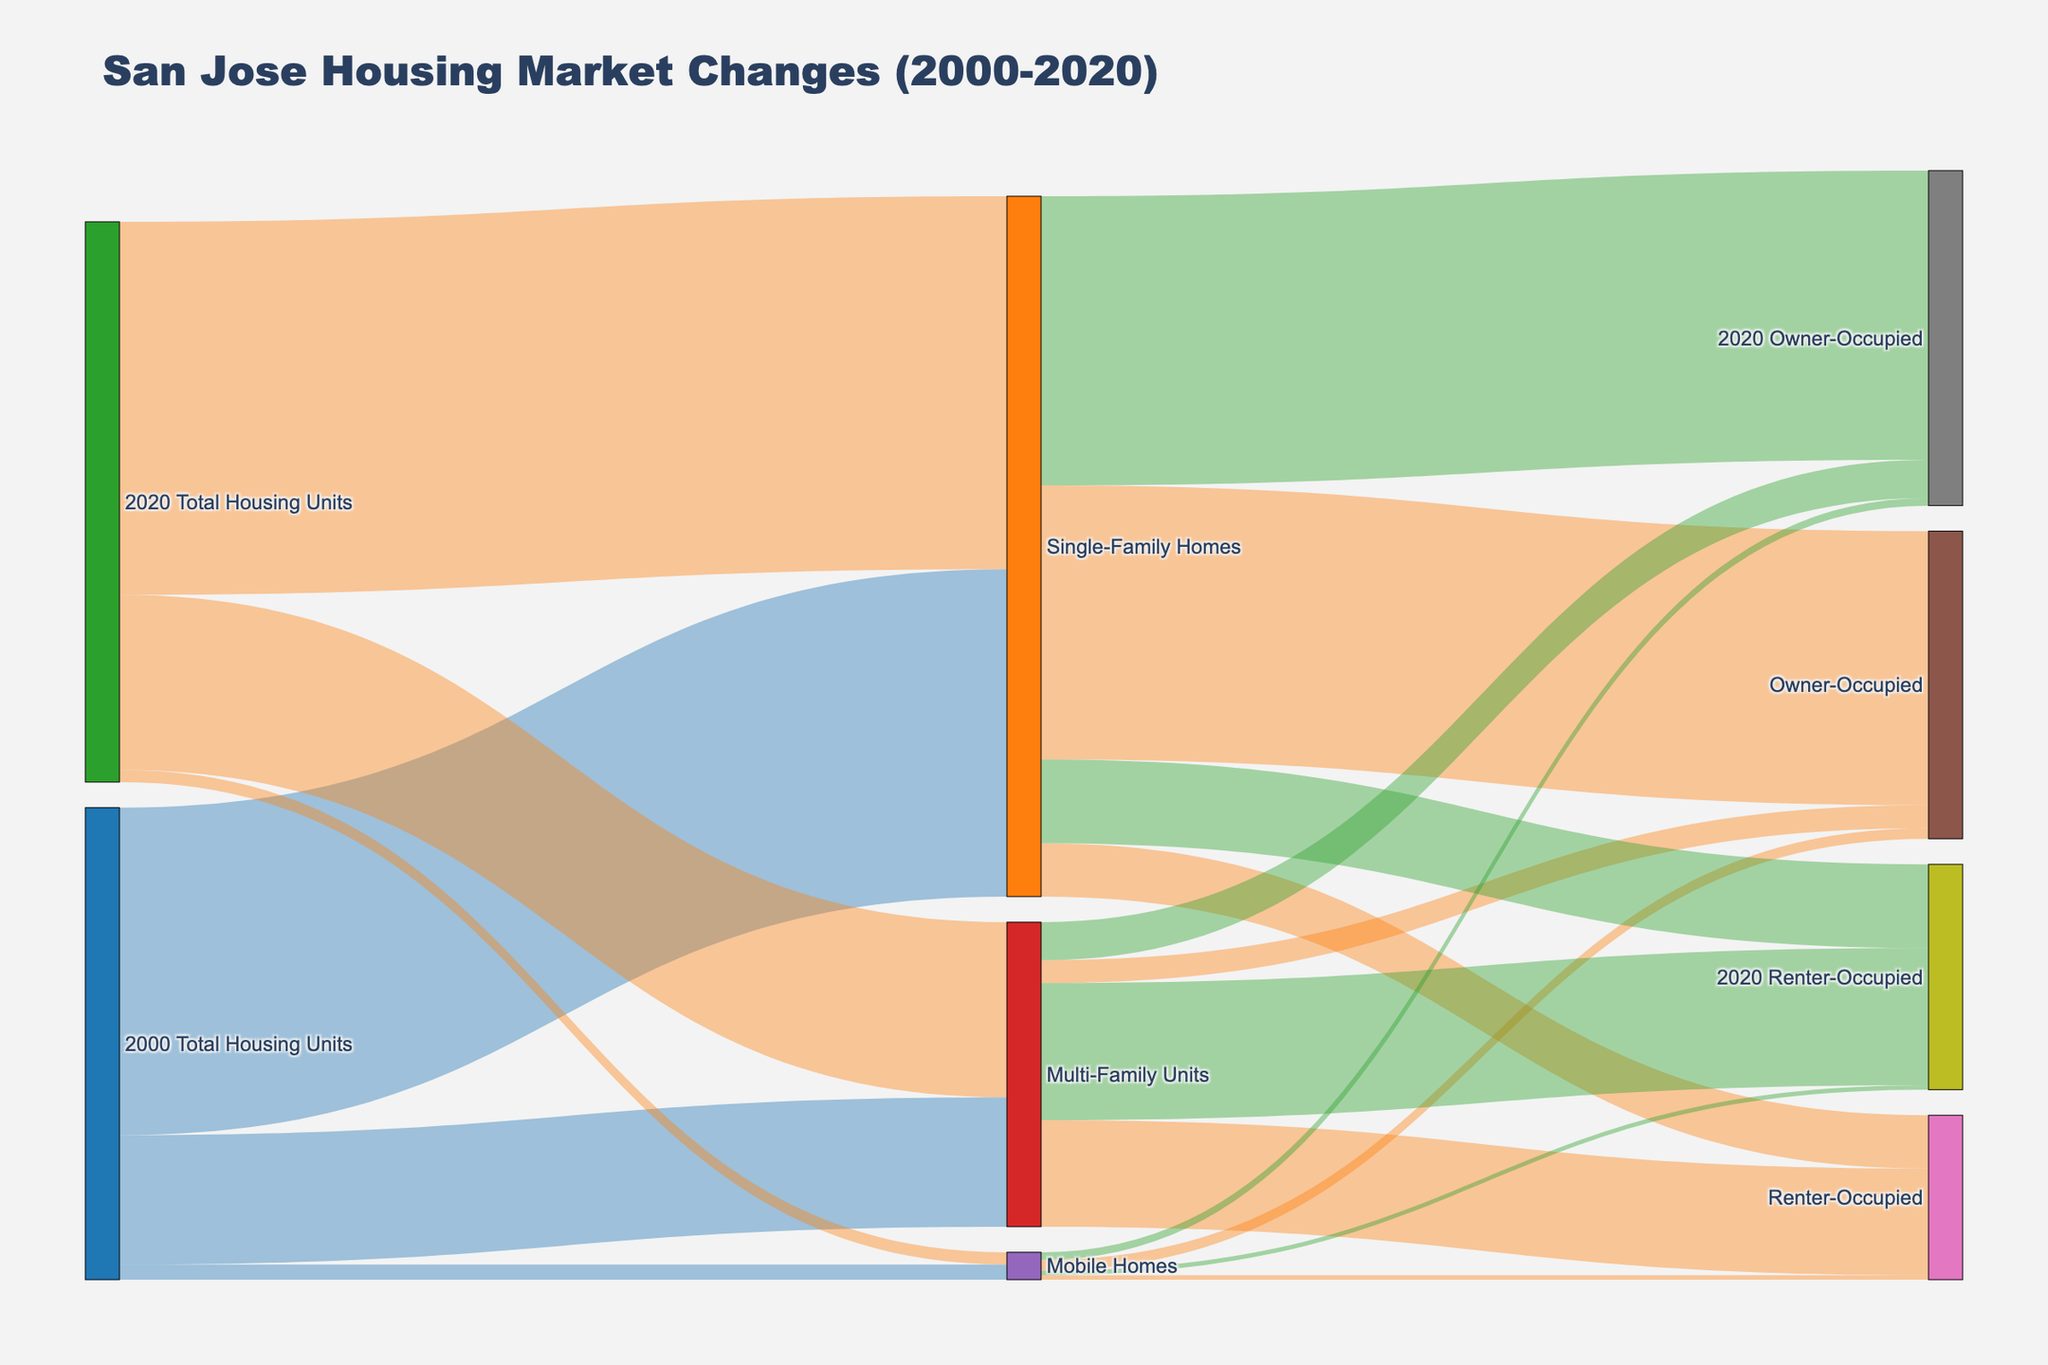How many total housing units were there in 2000? Looking at the first node "2000 Total Housing Units," we can sum the values directed to the housing types: 215,000 (Single-Family Homes) + 85,000 (Multi-Family Units) + 10,000 (Mobile Homes).
Answer: 310,000 How did the number of Single-Family Homes change from 2000 to 2020? From the diagram, Single-Family Homes in 2000 were 215,000 and rose to 245,000 in 2020.
Answer: Increased by 30,000 What color represents Mobile Homes in the diagram? The color in the node list for Mobile Homes is indicated as purple or similar shade (visual check).
Answer: Purple Which housing type had the most significant increase in renter-occupied units from 2000 to 2020? For the renter-occupied category, the values for 2000 and 2020 are: Single-Family Homes (35,000 to 55,000), Multi-Family Units (70,000 to 90,000), Mobile Homes (3,000 to 3,000). The Multi-Family Units had the largest increase of 20,000.
Answer: Multi-Family Units How many owner-occupied Single-Family Homes were there in 2020? Look at the link leading to “2020 Owner-Occupied” from "Single-Family Homes" in the 2020 block, which shows a value of 190,000.
Answer: 190,000 What’s the percentage increase in Multi-Family Units from 2000 to 2020? The Multi-Family Units in 2000 were 85,000 and in 2020 they were 115,000. The percentage increase is calculated as ((115,000 - 85,000) / 85,000) * 100.
Answer: 35.3% Which had a decrease in the total number of units from 2000 to 2020: Mobile Homes, Single-Family Homes, or Multi-Family Units? Mobile Homes decreased from 10,000 to 8,000 as seen in the diagram, while both Single-Family Homes and Multi-Family Units increased.
Answer: Mobile Homes Which type of occupancy for Mobile Homes did not change from 2000 to 2020? For Mobile Homes, the renter-occupied units remained the same at 3,000 from the 2000 and 2020 data.
Answer: Renter-Occupied Compare the change in owner-occupied units of Single-Family Homes versus Multi-Family Units between 2000 and 2020. Single-Family Homes increased from 180,000 to 190,000 (10,000 increase), Multi-Family Units increased from 15,000 to 25,000 (10,000 increase).
Answer: Both increased by 10,000 